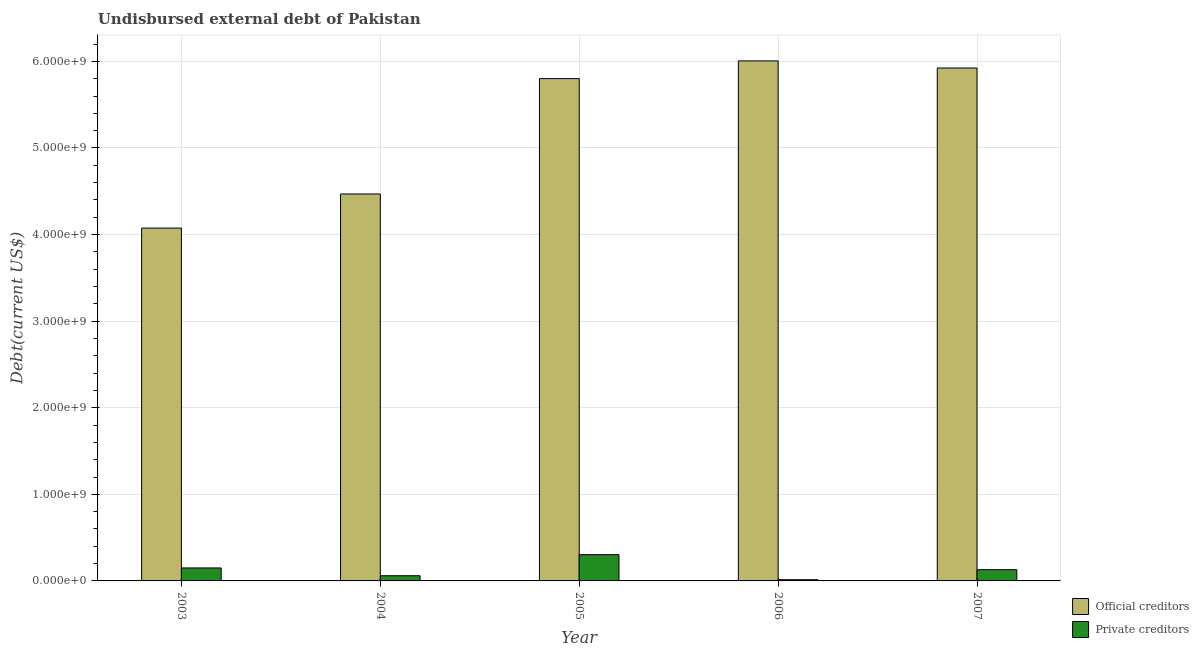How many different coloured bars are there?
Your answer should be compact. 2. Are the number of bars per tick equal to the number of legend labels?
Ensure brevity in your answer.  Yes. How many bars are there on the 3rd tick from the left?
Keep it short and to the point. 2. What is the undisbursed external debt of private creditors in 2003?
Keep it short and to the point. 1.50e+08. Across all years, what is the maximum undisbursed external debt of private creditors?
Ensure brevity in your answer.  3.03e+08. Across all years, what is the minimum undisbursed external debt of private creditors?
Give a very brief answer. 1.42e+07. What is the total undisbursed external debt of private creditors in the graph?
Give a very brief answer. 6.57e+08. What is the difference between the undisbursed external debt of private creditors in 2003 and that in 2004?
Make the answer very short. 8.97e+07. What is the difference between the undisbursed external debt of official creditors in 2005 and the undisbursed external debt of private creditors in 2007?
Provide a succinct answer. -1.23e+08. What is the average undisbursed external debt of official creditors per year?
Your response must be concise. 5.25e+09. In how many years, is the undisbursed external debt of private creditors greater than 4200000000 US$?
Keep it short and to the point. 0. What is the ratio of the undisbursed external debt of private creditors in 2005 to that in 2007?
Make the answer very short. 2.34. Is the undisbursed external debt of official creditors in 2006 less than that in 2007?
Keep it short and to the point. No. Is the difference between the undisbursed external debt of official creditors in 2005 and 2006 greater than the difference between the undisbursed external debt of private creditors in 2005 and 2006?
Your response must be concise. No. What is the difference between the highest and the second highest undisbursed external debt of official creditors?
Your response must be concise. 8.21e+07. What is the difference between the highest and the lowest undisbursed external debt of official creditors?
Make the answer very short. 1.93e+09. What does the 1st bar from the left in 2005 represents?
Provide a succinct answer. Official creditors. What does the 2nd bar from the right in 2007 represents?
Provide a short and direct response. Official creditors. How many bars are there?
Your answer should be very brief. 10. Are all the bars in the graph horizontal?
Your answer should be very brief. No. How many years are there in the graph?
Provide a short and direct response. 5. What is the difference between two consecutive major ticks on the Y-axis?
Ensure brevity in your answer.  1.00e+09. Are the values on the major ticks of Y-axis written in scientific E-notation?
Your answer should be very brief. Yes. Does the graph contain grids?
Provide a short and direct response. Yes. How many legend labels are there?
Make the answer very short. 2. What is the title of the graph?
Your answer should be compact. Undisbursed external debt of Pakistan. Does "Old" appear as one of the legend labels in the graph?
Your answer should be compact. No. What is the label or title of the Y-axis?
Give a very brief answer. Debt(current US$). What is the Debt(current US$) in Official creditors in 2003?
Provide a succinct answer. 4.07e+09. What is the Debt(current US$) in Private creditors in 2003?
Offer a very short reply. 1.50e+08. What is the Debt(current US$) of Official creditors in 2004?
Offer a very short reply. 4.47e+09. What is the Debt(current US$) of Private creditors in 2004?
Your answer should be very brief. 6.01e+07. What is the Debt(current US$) in Official creditors in 2005?
Your response must be concise. 5.80e+09. What is the Debt(current US$) in Private creditors in 2005?
Give a very brief answer. 3.03e+08. What is the Debt(current US$) of Official creditors in 2006?
Your answer should be very brief. 6.01e+09. What is the Debt(current US$) of Private creditors in 2006?
Provide a succinct answer. 1.42e+07. What is the Debt(current US$) in Official creditors in 2007?
Your answer should be compact. 5.92e+09. What is the Debt(current US$) in Private creditors in 2007?
Give a very brief answer. 1.30e+08. Across all years, what is the maximum Debt(current US$) of Official creditors?
Give a very brief answer. 6.01e+09. Across all years, what is the maximum Debt(current US$) of Private creditors?
Keep it short and to the point. 3.03e+08. Across all years, what is the minimum Debt(current US$) in Official creditors?
Keep it short and to the point. 4.07e+09. Across all years, what is the minimum Debt(current US$) of Private creditors?
Provide a succinct answer. 1.42e+07. What is the total Debt(current US$) of Official creditors in the graph?
Ensure brevity in your answer.  2.63e+1. What is the total Debt(current US$) in Private creditors in the graph?
Your answer should be very brief. 6.57e+08. What is the difference between the Debt(current US$) in Official creditors in 2003 and that in 2004?
Your response must be concise. -3.94e+08. What is the difference between the Debt(current US$) in Private creditors in 2003 and that in 2004?
Your answer should be very brief. 8.97e+07. What is the difference between the Debt(current US$) in Official creditors in 2003 and that in 2005?
Provide a succinct answer. -1.73e+09. What is the difference between the Debt(current US$) of Private creditors in 2003 and that in 2005?
Keep it short and to the point. -1.54e+08. What is the difference between the Debt(current US$) of Official creditors in 2003 and that in 2006?
Give a very brief answer. -1.93e+09. What is the difference between the Debt(current US$) in Private creditors in 2003 and that in 2006?
Your answer should be very brief. 1.36e+08. What is the difference between the Debt(current US$) in Official creditors in 2003 and that in 2007?
Your answer should be compact. -1.85e+09. What is the difference between the Debt(current US$) in Private creditors in 2003 and that in 2007?
Your answer should be compact. 2.01e+07. What is the difference between the Debt(current US$) in Official creditors in 2004 and that in 2005?
Your answer should be compact. -1.33e+09. What is the difference between the Debt(current US$) of Private creditors in 2004 and that in 2005?
Provide a short and direct response. -2.43e+08. What is the difference between the Debt(current US$) of Official creditors in 2004 and that in 2006?
Your answer should be compact. -1.54e+09. What is the difference between the Debt(current US$) in Private creditors in 2004 and that in 2006?
Provide a short and direct response. 4.59e+07. What is the difference between the Debt(current US$) of Official creditors in 2004 and that in 2007?
Your response must be concise. -1.45e+09. What is the difference between the Debt(current US$) in Private creditors in 2004 and that in 2007?
Your answer should be compact. -6.96e+07. What is the difference between the Debt(current US$) in Official creditors in 2005 and that in 2006?
Give a very brief answer. -2.05e+08. What is the difference between the Debt(current US$) in Private creditors in 2005 and that in 2006?
Offer a terse response. 2.89e+08. What is the difference between the Debt(current US$) in Official creditors in 2005 and that in 2007?
Your answer should be compact. -1.23e+08. What is the difference between the Debt(current US$) in Private creditors in 2005 and that in 2007?
Offer a terse response. 1.74e+08. What is the difference between the Debt(current US$) in Official creditors in 2006 and that in 2007?
Provide a succinct answer. 8.21e+07. What is the difference between the Debt(current US$) in Private creditors in 2006 and that in 2007?
Offer a very short reply. -1.15e+08. What is the difference between the Debt(current US$) of Official creditors in 2003 and the Debt(current US$) of Private creditors in 2004?
Keep it short and to the point. 4.01e+09. What is the difference between the Debt(current US$) in Official creditors in 2003 and the Debt(current US$) in Private creditors in 2005?
Your response must be concise. 3.77e+09. What is the difference between the Debt(current US$) in Official creditors in 2003 and the Debt(current US$) in Private creditors in 2006?
Ensure brevity in your answer.  4.06e+09. What is the difference between the Debt(current US$) of Official creditors in 2003 and the Debt(current US$) of Private creditors in 2007?
Your answer should be very brief. 3.95e+09. What is the difference between the Debt(current US$) in Official creditors in 2004 and the Debt(current US$) in Private creditors in 2005?
Give a very brief answer. 4.17e+09. What is the difference between the Debt(current US$) of Official creditors in 2004 and the Debt(current US$) of Private creditors in 2006?
Your response must be concise. 4.45e+09. What is the difference between the Debt(current US$) of Official creditors in 2004 and the Debt(current US$) of Private creditors in 2007?
Give a very brief answer. 4.34e+09. What is the difference between the Debt(current US$) in Official creditors in 2005 and the Debt(current US$) in Private creditors in 2006?
Provide a short and direct response. 5.79e+09. What is the difference between the Debt(current US$) in Official creditors in 2005 and the Debt(current US$) in Private creditors in 2007?
Your answer should be compact. 5.67e+09. What is the difference between the Debt(current US$) in Official creditors in 2006 and the Debt(current US$) in Private creditors in 2007?
Ensure brevity in your answer.  5.88e+09. What is the average Debt(current US$) of Official creditors per year?
Give a very brief answer. 5.25e+09. What is the average Debt(current US$) in Private creditors per year?
Provide a succinct answer. 1.31e+08. In the year 2003, what is the difference between the Debt(current US$) in Official creditors and Debt(current US$) in Private creditors?
Make the answer very short. 3.93e+09. In the year 2004, what is the difference between the Debt(current US$) in Official creditors and Debt(current US$) in Private creditors?
Give a very brief answer. 4.41e+09. In the year 2005, what is the difference between the Debt(current US$) of Official creditors and Debt(current US$) of Private creditors?
Your answer should be very brief. 5.50e+09. In the year 2006, what is the difference between the Debt(current US$) of Official creditors and Debt(current US$) of Private creditors?
Your answer should be very brief. 5.99e+09. In the year 2007, what is the difference between the Debt(current US$) in Official creditors and Debt(current US$) in Private creditors?
Offer a terse response. 5.79e+09. What is the ratio of the Debt(current US$) in Official creditors in 2003 to that in 2004?
Give a very brief answer. 0.91. What is the ratio of the Debt(current US$) of Private creditors in 2003 to that in 2004?
Provide a succinct answer. 2.49. What is the ratio of the Debt(current US$) of Official creditors in 2003 to that in 2005?
Keep it short and to the point. 0.7. What is the ratio of the Debt(current US$) in Private creditors in 2003 to that in 2005?
Offer a terse response. 0.49. What is the ratio of the Debt(current US$) in Official creditors in 2003 to that in 2006?
Make the answer very short. 0.68. What is the ratio of the Debt(current US$) in Private creditors in 2003 to that in 2006?
Provide a succinct answer. 10.53. What is the ratio of the Debt(current US$) in Official creditors in 2003 to that in 2007?
Ensure brevity in your answer.  0.69. What is the ratio of the Debt(current US$) of Private creditors in 2003 to that in 2007?
Offer a very short reply. 1.16. What is the ratio of the Debt(current US$) of Official creditors in 2004 to that in 2005?
Ensure brevity in your answer.  0.77. What is the ratio of the Debt(current US$) of Private creditors in 2004 to that in 2005?
Your response must be concise. 0.2. What is the ratio of the Debt(current US$) of Official creditors in 2004 to that in 2006?
Your answer should be very brief. 0.74. What is the ratio of the Debt(current US$) in Private creditors in 2004 to that in 2006?
Offer a terse response. 4.22. What is the ratio of the Debt(current US$) in Official creditors in 2004 to that in 2007?
Keep it short and to the point. 0.75. What is the ratio of the Debt(current US$) of Private creditors in 2004 to that in 2007?
Provide a succinct answer. 0.46. What is the ratio of the Debt(current US$) in Official creditors in 2005 to that in 2006?
Offer a terse response. 0.97. What is the ratio of the Debt(current US$) of Private creditors in 2005 to that in 2006?
Make the answer very short. 21.33. What is the ratio of the Debt(current US$) of Official creditors in 2005 to that in 2007?
Offer a terse response. 0.98. What is the ratio of the Debt(current US$) in Private creditors in 2005 to that in 2007?
Make the answer very short. 2.34. What is the ratio of the Debt(current US$) of Official creditors in 2006 to that in 2007?
Keep it short and to the point. 1.01. What is the ratio of the Debt(current US$) of Private creditors in 2006 to that in 2007?
Keep it short and to the point. 0.11. What is the difference between the highest and the second highest Debt(current US$) in Official creditors?
Keep it short and to the point. 8.21e+07. What is the difference between the highest and the second highest Debt(current US$) of Private creditors?
Give a very brief answer. 1.54e+08. What is the difference between the highest and the lowest Debt(current US$) in Official creditors?
Keep it short and to the point. 1.93e+09. What is the difference between the highest and the lowest Debt(current US$) in Private creditors?
Offer a terse response. 2.89e+08. 